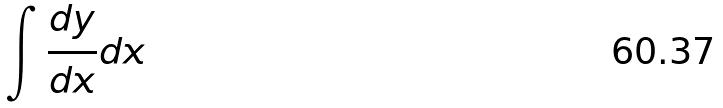Convert formula to latex. <formula><loc_0><loc_0><loc_500><loc_500>\int \frac { d y } { d x } d x</formula> 